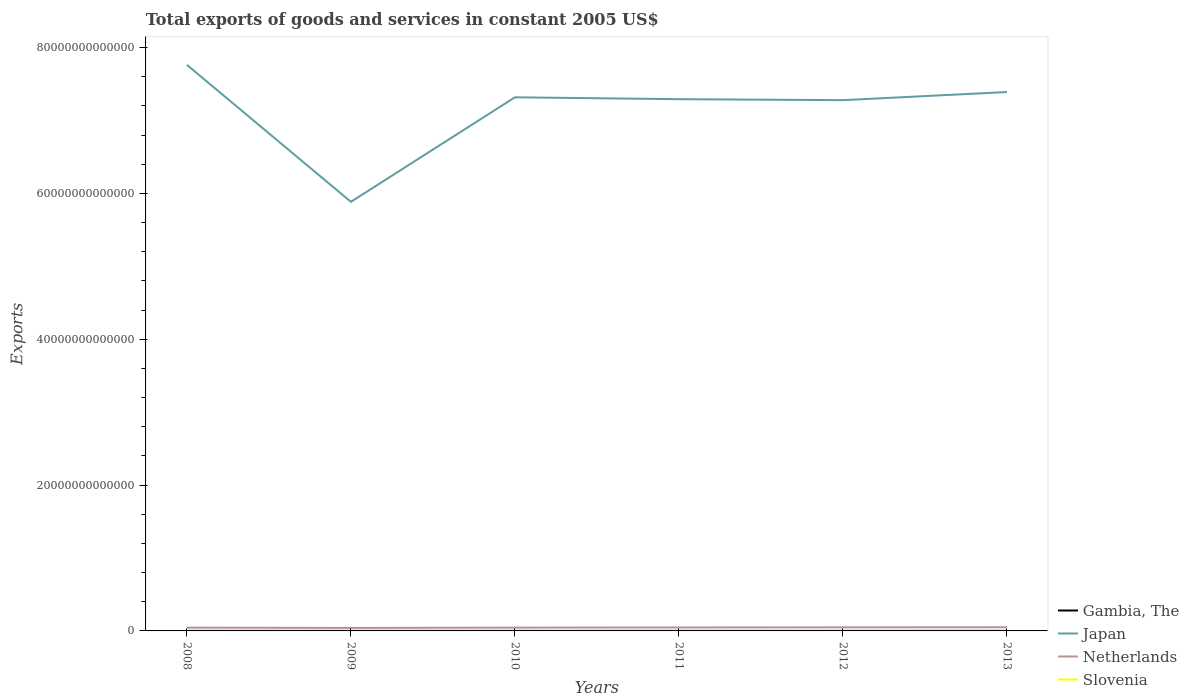How many different coloured lines are there?
Keep it short and to the point. 4. Is the number of lines equal to the number of legend labels?
Keep it short and to the point. Yes. Across all years, what is the maximum total exports of goods and services in Japan?
Ensure brevity in your answer.  5.88e+13. What is the total total exports of goods and services in Japan in the graph?
Your response must be concise. 1.88e+13. What is the difference between the highest and the second highest total exports of goods and services in Slovenia?
Give a very brief answer. 4.67e+09. What is the difference between the highest and the lowest total exports of goods and services in Gambia, The?
Provide a short and direct response. 3. Is the total exports of goods and services in Gambia, The strictly greater than the total exports of goods and services in Netherlands over the years?
Offer a very short reply. Yes. How many lines are there?
Your answer should be compact. 4. What is the difference between two consecutive major ticks on the Y-axis?
Provide a short and direct response. 2.00e+13. Does the graph contain any zero values?
Provide a succinct answer. No. Does the graph contain grids?
Offer a very short reply. No. What is the title of the graph?
Offer a very short reply. Total exports of goods and services in constant 2005 US$. Does "Latin America(all income levels)" appear as one of the legend labels in the graph?
Give a very brief answer. No. What is the label or title of the X-axis?
Offer a very short reply. Years. What is the label or title of the Y-axis?
Ensure brevity in your answer.  Exports. What is the Exports of Gambia, The in 2008?
Give a very brief answer. 3.05e+09. What is the Exports in Japan in 2008?
Ensure brevity in your answer.  7.76e+13. What is the Exports of Netherlands in 2008?
Offer a very short reply. 4.51e+11. What is the Exports of Slovenia in 2008?
Your response must be concise. 2.54e+1. What is the Exports of Gambia, The in 2009?
Your answer should be very brief. 4.56e+09. What is the Exports of Japan in 2009?
Ensure brevity in your answer.  5.88e+13. What is the Exports of Netherlands in 2009?
Your response must be concise. 4.11e+11. What is the Exports of Slovenia in 2009?
Keep it short and to the point. 2.12e+1. What is the Exports in Gambia, The in 2010?
Make the answer very short. 5.14e+09. What is the Exports in Japan in 2010?
Offer a very short reply. 7.32e+13. What is the Exports of Netherlands in 2010?
Provide a succinct answer. 4.54e+11. What is the Exports of Slovenia in 2010?
Keep it short and to the point. 2.33e+1. What is the Exports in Gambia, The in 2011?
Offer a very short reply. 5.48e+09. What is the Exports of Japan in 2011?
Offer a terse response. 7.29e+13. What is the Exports of Netherlands in 2011?
Keep it short and to the point. 4.74e+11. What is the Exports of Slovenia in 2011?
Provide a short and direct response. 2.49e+1. What is the Exports in Gambia, The in 2012?
Your answer should be compact. 6.75e+09. What is the Exports in Japan in 2012?
Your answer should be compact. 7.28e+13. What is the Exports of Netherlands in 2012?
Keep it short and to the point. 4.92e+11. What is the Exports in Slovenia in 2012?
Offer a terse response. 2.51e+1. What is the Exports of Gambia, The in 2013?
Your response must be concise. 6.73e+09. What is the Exports in Japan in 2013?
Your response must be concise. 7.39e+13. What is the Exports in Netherlands in 2013?
Your response must be concise. 5.03e+11. What is the Exports in Slovenia in 2013?
Ensure brevity in your answer.  2.58e+1. Across all years, what is the maximum Exports in Gambia, The?
Your answer should be compact. 6.75e+09. Across all years, what is the maximum Exports of Japan?
Give a very brief answer. 7.76e+13. Across all years, what is the maximum Exports of Netherlands?
Offer a terse response. 5.03e+11. Across all years, what is the maximum Exports of Slovenia?
Your answer should be compact. 2.58e+1. Across all years, what is the minimum Exports of Gambia, The?
Your answer should be very brief. 3.05e+09. Across all years, what is the minimum Exports in Japan?
Keep it short and to the point. 5.88e+13. Across all years, what is the minimum Exports of Netherlands?
Ensure brevity in your answer.  4.11e+11. Across all years, what is the minimum Exports of Slovenia?
Give a very brief answer. 2.12e+1. What is the total Exports of Gambia, The in the graph?
Provide a short and direct response. 3.17e+1. What is the total Exports of Japan in the graph?
Your answer should be compact. 4.29e+14. What is the total Exports of Netherlands in the graph?
Your answer should be compact. 2.79e+12. What is the total Exports of Slovenia in the graph?
Keep it short and to the point. 1.46e+11. What is the difference between the Exports in Gambia, The in 2008 and that in 2009?
Provide a short and direct response. -1.52e+09. What is the difference between the Exports of Japan in 2008 and that in 2009?
Offer a very short reply. 1.88e+13. What is the difference between the Exports of Netherlands in 2008 and that in 2009?
Give a very brief answer. 4.02e+1. What is the difference between the Exports of Slovenia in 2008 and that in 2009?
Your answer should be very brief. 4.21e+09. What is the difference between the Exports of Gambia, The in 2008 and that in 2010?
Offer a very short reply. -2.10e+09. What is the difference between the Exports of Japan in 2008 and that in 2010?
Provide a short and direct response. 4.45e+12. What is the difference between the Exports in Netherlands in 2008 and that in 2010?
Your answer should be compact. -3.14e+09. What is the difference between the Exports in Slovenia in 2008 and that in 2010?
Keep it short and to the point. 2.06e+09. What is the difference between the Exports of Gambia, The in 2008 and that in 2011?
Give a very brief answer. -2.43e+09. What is the difference between the Exports in Japan in 2008 and that in 2011?
Your response must be concise. 4.71e+12. What is the difference between the Exports in Netherlands in 2008 and that in 2011?
Make the answer very short. -2.32e+1. What is the difference between the Exports of Slovenia in 2008 and that in 2011?
Offer a very short reply. 4.52e+08. What is the difference between the Exports in Gambia, The in 2008 and that in 2012?
Offer a very short reply. -3.70e+09. What is the difference between the Exports in Japan in 2008 and that in 2012?
Your answer should be very brief. 4.84e+12. What is the difference between the Exports of Netherlands in 2008 and that in 2012?
Offer a very short reply. -4.11e+1. What is the difference between the Exports in Slovenia in 2008 and that in 2012?
Provide a succinct answer. 3.06e+08. What is the difference between the Exports in Gambia, The in 2008 and that in 2013?
Your answer should be very brief. -3.68e+09. What is the difference between the Exports of Japan in 2008 and that in 2013?
Give a very brief answer. 3.72e+12. What is the difference between the Exports of Netherlands in 2008 and that in 2013?
Provide a short and direct response. -5.17e+1. What is the difference between the Exports of Slovenia in 2008 and that in 2013?
Provide a succinct answer. -4.59e+08. What is the difference between the Exports of Gambia, The in 2009 and that in 2010?
Offer a very short reply. -5.81e+08. What is the difference between the Exports of Japan in 2009 and that in 2010?
Make the answer very short. -1.43e+13. What is the difference between the Exports of Netherlands in 2009 and that in 2010?
Make the answer very short. -4.33e+1. What is the difference between the Exports in Slovenia in 2009 and that in 2010?
Your answer should be compact. -2.15e+09. What is the difference between the Exports of Gambia, The in 2009 and that in 2011?
Keep it short and to the point. -9.14e+08. What is the difference between the Exports in Japan in 2009 and that in 2011?
Ensure brevity in your answer.  -1.41e+13. What is the difference between the Exports of Netherlands in 2009 and that in 2011?
Your response must be concise. -6.33e+1. What is the difference between the Exports in Slovenia in 2009 and that in 2011?
Provide a short and direct response. -3.76e+09. What is the difference between the Exports of Gambia, The in 2009 and that in 2012?
Offer a terse response. -2.18e+09. What is the difference between the Exports of Japan in 2009 and that in 2012?
Offer a very short reply. -1.39e+13. What is the difference between the Exports of Netherlands in 2009 and that in 2012?
Keep it short and to the point. -8.13e+1. What is the difference between the Exports in Slovenia in 2009 and that in 2012?
Provide a short and direct response. -3.90e+09. What is the difference between the Exports of Gambia, The in 2009 and that in 2013?
Your answer should be compact. -2.16e+09. What is the difference between the Exports in Japan in 2009 and that in 2013?
Offer a very short reply. -1.51e+13. What is the difference between the Exports of Netherlands in 2009 and that in 2013?
Give a very brief answer. -9.19e+1. What is the difference between the Exports of Slovenia in 2009 and that in 2013?
Provide a succinct answer. -4.67e+09. What is the difference between the Exports in Gambia, The in 2010 and that in 2011?
Make the answer very short. -3.33e+08. What is the difference between the Exports of Japan in 2010 and that in 2011?
Give a very brief answer. 2.60e+11. What is the difference between the Exports in Netherlands in 2010 and that in 2011?
Offer a terse response. -2.00e+1. What is the difference between the Exports in Slovenia in 2010 and that in 2011?
Give a very brief answer. -1.61e+09. What is the difference between the Exports in Gambia, The in 2010 and that in 2012?
Your answer should be compact. -1.60e+09. What is the difference between the Exports of Japan in 2010 and that in 2012?
Ensure brevity in your answer.  3.92e+11. What is the difference between the Exports in Netherlands in 2010 and that in 2012?
Your response must be concise. -3.80e+1. What is the difference between the Exports of Slovenia in 2010 and that in 2012?
Give a very brief answer. -1.75e+09. What is the difference between the Exports in Gambia, The in 2010 and that in 2013?
Give a very brief answer. -1.58e+09. What is the difference between the Exports of Japan in 2010 and that in 2013?
Provide a succinct answer. -7.21e+11. What is the difference between the Exports of Netherlands in 2010 and that in 2013?
Your answer should be very brief. -4.86e+1. What is the difference between the Exports in Slovenia in 2010 and that in 2013?
Provide a succinct answer. -2.52e+09. What is the difference between the Exports of Gambia, The in 2011 and that in 2012?
Provide a short and direct response. -1.27e+09. What is the difference between the Exports of Japan in 2011 and that in 2012?
Give a very brief answer. 1.32e+11. What is the difference between the Exports of Netherlands in 2011 and that in 2012?
Give a very brief answer. -1.80e+1. What is the difference between the Exports of Slovenia in 2011 and that in 2012?
Your answer should be very brief. -1.46e+08. What is the difference between the Exports in Gambia, The in 2011 and that in 2013?
Your response must be concise. -1.25e+09. What is the difference between the Exports of Japan in 2011 and that in 2013?
Give a very brief answer. -9.81e+11. What is the difference between the Exports of Netherlands in 2011 and that in 2013?
Your answer should be compact. -2.86e+1. What is the difference between the Exports of Slovenia in 2011 and that in 2013?
Provide a succinct answer. -9.11e+08. What is the difference between the Exports of Gambia, The in 2012 and that in 2013?
Your answer should be very brief. 2.00e+07. What is the difference between the Exports in Japan in 2012 and that in 2013?
Give a very brief answer. -1.11e+12. What is the difference between the Exports in Netherlands in 2012 and that in 2013?
Provide a short and direct response. -1.06e+1. What is the difference between the Exports in Slovenia in 2012 and that in 2013?
Keep it short and to the point. -7.65e+08. What is the difference between the Exports in Gambia, The in 2008 and the Exports in Japan in 2009?
Make the answer very short. -5.88e+13. What is the difference between the Exports in Gambia, The in 2008 and the Exports in Netherlands in 2009?
Offer a very short reply. -4.08e+11. What is the difference between the Exports in Gambia, The in 2008 and the Exports in Slovenia in 2009?
Provide a short and direct response. -1.81e+1. What is the difference between the Exports of Japan in 2008 and the Exports of Netherlands in 2009?
Provide a short and direct response. 7.72e+13. What is the difference between the Exports in Japan in 2008 and the Exports in Slovenia in 2009?
Ensure brevity in your answer.  7.76e+13. What is the difference between the Exports of Netherlands in 2008 and the Exports of Slovenia in 2009?
Provide a short and direct response. 4.30e+11. What is the difference between the Exports in Gambia, The in 2008 and the Exports in Japan in 2010?
Your response must be concise. -7.32e+13. What is the difference between the Exports in Gambia, The in 2008 and the Exports in Netherlands in 2010?
Provide a succinct answer. -4.51e+11. What is the difference between the Exports of Gambia, The in 2008 and the Exports of Slovenia in 2010?
Make the answer very short. -2.03e+1. What is the difference between the Exports in Japan in 2008 and the Exports in Netherlands in 2010?
Provide a short and direct response. 7.72e+13. What is the difference between the Exports in Japan in 2008 and the Exports in Slovenia in 2010?
Offer a very short reply. 7.76e+13. What is the difference between the Exports of Netherlands in 2008 and the Exports of Slovenia in 2010?
Provide a succinct answer. 4.28e+11. What is the difference between the Exports in Gambia, The in 2008 and the Exports in Japan in 2011?
Ensure brevity in your answer.  -7.29e+13. What is the difference between the Exports of Gambia, The in 2008 and the Exports of Netherlands in 2011?
Provide a succinct answer. -4.71e+11. What is the difference between the Exports of Gambia, The in 2008 and the Exports of Slovenia in 2011?
Keep it short and to the point. -2.19e+1. What is the difference between the Exports in Japan in 2008 and the Exports in Netherlands in 2011?
Your response must be concise. 7.72e+13. What is the difference between the Exports of Japan in 2008 and the Exports of Slovenia in 2011?
Make the answer very short. 7.76e+13. What is the difference between the Exports in Netherlands in 2008 and the Exports in Slovenia in 2011?
Your response must be concise. 4.26e+11. What is the difference between the Exports of Gambia, The in 2008 and the Exports of Japan in 2012?
Offer a very short reply. -7.28e+13. What is the difference between the Exports of Gambia, The in 2008 and the Exports of Netherlands in 2012?
Your response must be concise. -4.89e+11. What is the difference between the Exports of Gambia, The in 2008 and the Exports of Slovenia in 2012?
Give a very brief answer. -2.20e+1. What is the difference between the Exports in Japan in 2008 and the Exports in Netherlands in 2012?
Your response must be concise. 7.71e+13. What is the difference between the Exports of Japan in 2008 and the Exports of Slovenia in 2012?
Provide a succinct answer. 7.76e+13. What is the difference between the Exports in Netherlands in 2008 and the Exports in Slovenia in 2012?
Keep it short and to the point. 4.26e+11. What is the difference between the Exports of Gambia, The in 2008 and the Exports of Japan in 2013?
Your response must be concise. -7.39e+13. What is the difference between the Exports of Gambia, The in 2008 and the Exports of Netherlands in 2013?
Ensure brevity in your answer.  -5.00e+11. What is the difference between the Exports of Gambia, The in 2008 and the Exports of Slovenia in 2013?
Your answer should be compact. -2.28e+1. What is the difference between the Exports in Japan in 2008 and the Exports in Netherlands in 2013?
Provide a short and direct response. 7.71e+13. What is the difference between the Exports of Japan in 2008 and the Exports of Slovenia in 2013?
Offer a terse response. 7.76e+13. What is the difference between the Exports of Netherlands in 2008 and the Exports of Slovenia in 2013?
Your response must be concise. 4.25e+11. What is the difference between the Exports in Gambia, The in 2009 and the Exports in Japan in 2010?
Offer a terse response. -7.32e+13. What is the difference between the Exports in Gambia, The in 2009 and the Exports in Netherlands in 2010?
Your answer should be compact. -4.50e+11. What is the difference between the Exports of Gambia, The in 2009 and the Exports of Slovenia in 2010?
Your response must be concise. -1.87e+1. What is the difference between the Exports in Japan in 2009 and the Exports in Netherlands in 2010?
Your answer should be compact. 5.84e+13. What is the difference between the Exports of Japan in 2009 and the Exports of Slovenia in 2010?
Your response must be concise. 5.88e+13. What is the difference between the Exports of Netherlands in 2009 and the Exports of Slovenia in 2010?
Ensure brevity in your answer.  3.88e+11. What is the difference between the Exports in Gambia, The in 2009 and the Exports in Japan in 2011?
Keep it short and to the point. -7.29e+13. What is the difference between the Exports of Gambia, The in 2009 and the Exports of Netherlands in 2011?
Your answer should be compact. -4.70e+11. What is the difference between the Exports in Gambia, The in 2009 and the Exports in Slovenia in 2011?
Make the answer very short. -2.03e+1. What is the difference between the Exports of Japan in 2009 and the Exports of Netherlands in 2011?
Keep it short and to the point. 5.84e+13. What is the difference between the Exports of Japan in 2009 and the Exports of Slovenia in 2011?
Offer a very short reply. 5.88e+13. What is the difference between the Exports in Netherlands in 2009 and the Exports in Slovenia in 2011?
Make the answer very short. 3.86e+11. What is the difference between the Exports in Gambia, The in 2009 and the Exports in Japan in 2012?
Your answer should be very brief. -7.28e+13. What is the difference between the Exports in Gambia, The in 2009 and the Exports in Netherlands in 2012?
Keep it short and to the point. -4.88e+11. What is the difference between the Exports in Gambia, The in 2009 and the Exports in Slovenia in 2012?
Your answer should be very brief. -2.05e+1. What is the difference between the Exports of Japan in 2009 and the Exports of Netherlands in 2012?
Your answer should be very brief. 5.84e+13. What is the difference between the Exports in Japan in 2009 and the Exports in Slovenia in 2012?
Make the answer very short. 5.88e+13. What is the difference between the Exports of Netherlands in 2009 and the Exports of Slovenia in 2012?
Your answer should be very brief. 3.86e+11. What is the difference between the Exports of Gambia, The in 2009 and the Exports of Japan in 2013?
Offer a very short reply. -7.39e+13. What is the difference between the Exports of Gambia, The in 2009 and the Exports of Netherlands in 2013?
Provide a succinct answer. -4.98e+11. What is the difference between the Exports in Gambia, The in 2009 and the Exports in Slovenia in 2013?
Ensure brevity in your answer.  -2.13e+1. What is the difference between the Exports of Japan in 2009 and the Exports of Netherlands in 2013?
Ensure brevity in your answer.  5.83e+13. What is the difference between the Exports of Japan in 2009 and the Exports of Slovenia in 2013?
Offer a terse response. 5.88e+13. What is the difference between the Exports of Netherlands in 2009 and the Exports of Slovenia in 2013?
Give a very brief answer. 3.85e+11. What is the difference between the Exports of Gambia, The in 2010 and the Exports of Japan in 2011?
Your answer should be compact. -7.29e+13. What is the difference between the Exports of Gambia, The in 2010 and the Exports of Netherlands in 2011?
Provide a succinct answer. -4.69e+11. What is the difference between the Exports in Gambia, The in 2010 and the Exports in Slovenia in 2011?
Provide a succinct answer. -1.98e+1. What is the difference between the Exports of Japan in 2010 and the Exports of Netherlands in 2011?
Provide a succinct answer. 7.27e+13. What is the difference between the Exports in Japan in 2010 and the Exports in Slovenia in 2011?
Provide a succinct answer. 7.32e+13. What is the difference between the Exports of Netherlands in 2010 and the Exports of Slovenia in 2011?
Your answer should be compact. 4.29e+11. What is the difference between the Exports of Gambia, The in 2010 and the Exports of Japan in 2012?
Ensure brevity in your answer.  -7.28e+13. What is the difference between the Exports of Gambia, The in 2010 and the Exports of Netherlands in 2012?
Give a very brief answer. -4.87e+11. What is the difference between the Exports of Gambia, The in 2010 and the Exports of Slovenia in 2012?
Your response must be concise. -1.99e+1. What is the difference between the Exports of Japan in 2010 and the Exports of Netherlands in 2012?
Give a very brief answer. 7.27e+13. What is the difference between the Exports of Japan in 2010 and the Exports of Slovenia in 2012?
Provide a succinct answer. 7.32e+13. What is the difference between the Exports in Netherlands in 2010 and the Exports in Slovenia in 2012?
Make the answer very short. 4.29e+11. What is the difference between the Exports of Gambia, The in 2010 and the Exports of Japan in 2013?
Make the answer very short. -7.39e+13. What is the difference between the Exports in Gambia, The in 2010 and the Exports in Netherlands in 2013?
Provide a short and direct response. -4.98e+11. What is the difference between the Exports of Gambia, The in 2010 and the Exports of Slovenia in 2013?
Your answer should be compact. -2.07e+1. What is the difference between the Exports in Japan in 2010 and the Exports in Netherlands in 2013?
Your response must be concise. 7.27e+13. What is the difference between the Exports of Japan in 2010 and the Exports of Slovenia in 2013?
Keep it short and to the point. 7.32e+13. What is the difference between the Exports of Netherlands in 2010 and the Exports of Slovenia in 2013?
Provide a succinct answer. 4.29e+11. What is the difference between the Exports in Gambia, The in 2011 and the Exports in Japan in 2012?
Offer a very short reply. -7.28e+13. What is the difference between the Exports in Gambia, The in 2011 and the Exports in Netherlands in 2012?
Keep it short and to the point. -4.87e+11. What is the difference between the Exports of Gambia, The in 2011 and the Exports of Slovenia in 2012?
Offer a very short reply. -1.96e+1. What is the difference between the Exports in Japan in 2011 and the Exports in Netherlands in 2012?
Offer a terse response. 7.24e+13. What is the difference between the Exports of Japan in 2011 and the Exports of Slovenia in 2012?
Ensure brevity in your answer.  7.29e+13. What is the difference between the Exports in Netherlands in 2011 and the Exports in Slovenia in 2012?
Provide a succinct answer. 4.49e+11. What is the difference between the Exports of Gambia, The in 2011 and the Exports of Japan in 2013?
Provide a short and direct response. -7.39e+13. What is the difference between the Exports in Gambia, The in 2011 and the Exports in Netherlands in 2013?
Ensure brevity in your answer.  -4.98e+11. What is the difference between the Exports of Gambia, The in 2011 and the Exports of Slovenia in 2013?
Your answer should be compact. -2.03e+1. What is the difference between the Exports in Japan in 2011 and the Exports in Netherlands in 2013?
Your answer should be compact. 7.24e+13. What is the difference between the Exports in Japan in 2011 and the Exports in Slovenia in 2013?
Your answer should be very brief. 7.29e+13. What is the difference between the Exports of Netherlands in 2011 and the Exports of Slovenia in 2013?
Your answer should be compact. 4.49e+11. What is the difference between the Exports of Gambia, The in 2012 and the Exports of Japan in 2013?
Your response must be concise. -7.39e+13. What is the difference between the Exports of Gambia, The in 2012 and the Exports of Netherlands in 2013?
Provide a succinct answer. -4.96e+11. What is the difference between the Exports of Gambia, The in 2012 and the Exports of Slovenia in 2013?
Offer a very short reply. -1.91e+1. What is the difference between the Exports in Japan in 2012 and the Exports in Netherlands in 2013?
Your answer should be compact. 7.23e+13. What is the difference between the Exports of Japan in 2012 and the Exports of Slovenia in 2013?
Keep it short and to the point. 7.28e+13. What is the difference between the Exports of Netherlands in 2012 and the Exports of Slovenia in 2013?
Offer a very short reply. 4.67e+11. What is the average Exports in Gambia, The per year?
Give a very brief answer. 5.28e+09. What is the average Exports in Japan per year?
Provide a short and direct response. 7.15e+13. What is the average Exports of Netherlands per year?
Your answer should be compact. 4.64e+11. What is the average Exports in Slovenia per year?
Your answer should be very brief. 2.43e+1. In the year 2008, what is the difference between the Exports of Gambia, The and Exports of Japan?
Provide a succinct answer. -7.76e+13. In the year 2008, what is the difference between the Exports in Gambia, The and Exports in Netherlands?
Your answer should be compact. -4.48e+11. In the year 2008, what is the difference between the Exports of Gambia, The and Exports of Slovenia?
Offer a very short reply. -2.23e+1. In the year 2008, what is the difference between the Exports of Japan and Exports of Netherlands?
Give a very brief answer. 7.72e+13. In the year 2008, what is the difference between the Exports of Japan and Exports of Slovenia?
Give a very brief answer. 7.76e+13. In the year 2008, what is the difference between the Exports of Netherlands and Exports of Slovenia?
Give a very brief answer. 4.26e+11. In the year 2009, what is the difference between the Exports of Gambia, The and Exports of Japan?
Ensure brevity in your answer.  -5.88e+13. In the year 2009, what is the difference between the Exports in Gambia, The and Exports in Netherlands?
Offer a terse response. -4.07e+11. In the year 2009, what is the difference between the Exports in Gambia, The and Exports in Slovenia?
Offer a very short reply. -1.66e+1. In the year 2009, what is the difference between the Exports in Japan and Exports in Netherlands?
Provide a short and direct response. 5.84e+13. In the year 2009, what is the difference between the Exports in Japan and Exports in Slovenia?
Your answer should be very brief. 5.88e+13. In the year 2009, what is the difference between the Exports of Netherlands and Exports of Slovenia?
Provide a succinct answer. 3.90e+11. In the year 2010, what is the difference between the Exports of Gambia, The and Exports of Japan?
Offer a terse response. -7.32e+13. In the year 2010, what is the difference between the Exports in Gambia, The and Exports in Netherlands?
Provide a short and direct response. -4.49e+11. In the year 2010, what is the difference between the Exports in Gambia, The and Exports in Slovenia?
Keep it short and to the point. -1.82e+1. In the year 2010, what is the difference between the Exports of Japan and Exports of Netherlands?
Ensure brevity in your answer.  7.27e+13. In the year 2010, what is the difference between the Exports in Japan and Exports in Slovenia?
Give a very brief answer. 7.32e+13. In the year 2010, what is the difference between the Exports of Netherlands and Exports of Slovenia?
Offer a terse response. 4.31e+11. In the year 2011, what is the difference between the Exports of Gambia, The and Exports of Japan?
Make the answer very short. -7.29e+13. In the year 2011, what is the difference between the Exports of Gambia, The and Exports of Netherlands?
Your answer should be compact. -4.69e+11. In the year 2011, what is the difference between the Exports of Gambia, The and Exports of Slovenia?
Keep it short and to the point. -1.94e+1. In the year 2011, what is the difference between the Exports of Japan and Exports of Netherlands?
Provide a short and direct response. 7.24e+13. In the year 2011, what is the difference between the Exports in Japan and Exports in Slovenia?
Provide a succinct answer. 7.29e+13. In the year 2011, what is the difference between the Exports of Netherlands and Exports of Slovenia?
Your answer should be very brief. 4.49e+11. In the year 2012, what is the difference between the Exports of Gambia, The and Exports of Japan?
Your response must be concise. -7.28e+13. In the year 2012, what is the difference between the Exports in Gambia, The and Exports in Netherlands?
Your answer should be very brief. -4.86e+11. In the year 2012, what is the difference between the Exports in Gambia, The and Exports in Slovenia?
Provide a succinct answer. -1.83e+1. In the year 2012, what is the difference between the Exports of Japan and Exports of Netherlands?
Keep it short and to the point. 7.23e+13. In the year 2012, what is the difference between the Exports of Japan and Exports of Slovenia?
Offer a terse response. 7.28e+13. In the year 2012, what is the difference between the Exports of Netherlands and Exports of Slovenia?
Offer a terse response. 4.67e+11. In the year 2013, what is the difference between the Exports in Gambia, The and Exports in Japan?
Ensure brevity in your answer.  -7.39e+13. In the year 2013, what is the difference between the Exports of Gambia, The and Exports of Netherlands?
Your answer should be very brief. -4.96e+11. In the year 2013, what is the difference between the Exports of Gambia, The and Exports of Slovenia?
Make the answer very short. -1.91e+1. In the year 2013, what is the difference between the Exports in Japan and Exports in Netherlands?
Offer a terse response. 7.34e+13. In the year 2013, what is the difference between the Exports in Japan and Exports in Slovenia?
Your answer should be compact. 7.39e+13. In the year 2013, what is the difference between the Exports in Netherlands and Exports in Slovenia?
Offer a terse response. 4.77e+11. What is the ratio of the Exports in Gambia, The in 2008 to that in 2009?
Ensure brevity in your answer.  0.67. What is the ratio of the Exports of Japan in 2008 to that in 2009?
Offer a very short reply. 1.32. What is the ratio of the Exports of Netherlands in 2008 to that in 2009?
Make the answer very short. 1.1. What is the ratio of the Exports of Slovenia in 2008 to that in 2009?
Give a very brief answer. 1.2. What is the ratio of the Exports of Gambia, The in 2008 to that in 2010?
Your response must be concise. 0.59. What is the ratio of the Exports of Japan in 2008 to that in 2010?
Your answer should be compact. 1.06. What is the ratio of the Exports in Slovenia in 2008 to that in 2010?
Your response must be concise. 1.09. What is the ratio of the Exports in Gambia, The in 2008 to that in 2011?
Your answer should be very brief. 0.56. What is the ratio of the Exports of Japan in 2008 to that in 2011?
Ensure brevity in your answer.  1.06. What is the ratio of the Exports of Netherlands in 2008 to that in 2011?
Your answer should be very brief. 0.95. What is the ratio of the Exports of Slovenia in 2008 to that in 2011?
Ensure brevity in your answer.  1.02. What is the ratio of the Exports of Gambia, The in 2008 to that in 2012?
Provide a short and direct response. 0.45. What is the ratio of the Exports in Japan in 2008 to that in 2012?
Your answer should be very brief. 1.07. What is the ratio of the Exports of Netherlands in 2008 to that in 2012?
Give a very brief answer. 0.92. What is the ratio of the Exports in Slovenia in 2008 to that in 2012?
Your answer should be compact. 1.01. What is the ratio of the Exports in Gambia, The in 2008 to that in 2013?
Offer a very short reply. 0.45. What is the ratio of the Exports of Japan in 2008 to that in 2013?
Provide a short and direct response. 1.05. What is the ratio of the Exports in Netherlands in 2008 to that in 2013?
Ensure brevity in your answer.  0.9. What is the ratio of the Exports in Slovenia in 2008 to that in 2013?
Your response must be concise. 0.98. What is the ratio of the Exports of Gambia, The in 2009 to that in 2010?
Offer a very short reply. 0.89. What is the ratio of the Exports of Japan in 2009 to that in 2010?
Your response must be concise. 0.8. What is the ratio of the Exports in Netherlands in 2009 to that in 2010?
Make the answer very short. 0.9. What is the ratio of the Exports of Slovenia in 2009 to that in 2010?
Your response must be concise. 0.91. What is the ratio of the Exports of Gambia, The in 2009 to that in 2011?
Provide a succinct answer. 0.83. What is the ratio of the Exports of Japan in 2009 to that in 2011?
Provide a succinct answer. 0.81. What is the ratio of the Exports of Netherlands in 2009 to that in 2011?
Give a very brief answer. 0.87. What is the ratio of the Exports of Slovenia in 2009 to that in 2011?
Your answer should be very brief. 0.85. What is the ratio of the Exports in Gambia, The in 2009 to that in 2012?
Give a very brief answer. 0.68. What is the ratio of the Exports in Japan in 2009 to that in 2012?
Provide a succinct answer. 0.81. What is the ratio of the Exports of Netherlands in 2009 to that in 2012?
Your response must be concise. 0.83. What is the ratio of the Exports in Slovenia in 2009 to that in 2012?
Offer a very short reply. 0.84. What is the ratio of the Exports of Gambia, The in 2009 to that in 2013?
Give a very brief answer. 0.68. What is the ratio of the Exports of Japan in 2009 to that in 2013?
Offer a terse response. 0.8. What is the ratio of the Exports of Netherlands in 2009 to that in 2013?
Keep it short and to the point. 0.82. What is the ratio of the Exports in Slovenia in 2009 to that in 2013?
Keep it short and to the point. 0.82. What is the ratio of the Exports in Gambia, The in 2010 to that in 2011?
Your answer should be very brief. 0.94. What is the ratio of the Exports of Japan in 2010 to that in 2011?
Provide a short and direct response. 1. What is the ratio of the Exports of Netherlands in 2010 to that in 2011?
Your answer should be very brief. 0.96. What is the ratio of the Exports in Slovenia in 2010 to that in 2011?
Give a very brief answer. 0.94. What is the ratio of the Exports in Gambia, The in 2010 to that in 2012?
Give a very brief answer. 0.76. What is the ratio of the Exports of Japan in 2010 to that in 2012?
Make the answer very short. 1.01. What is the ratio of the Exports of Netherlands in 2010 to that in 2012?
Give a very brief answer. 0.92. What is the ratio of the Exports in Slovenia in 2010 to that in 2012?
Offer a very short reply. 0.93. What is the ratio of the Exports in Gambia, The in 2010 to that in 2013?
Make the answer very short. 0.76. What is the ratio of the Exports of Japan in 2010 to that in 2013?
Make the answer very short. 0.99. What is the ratio of the Exports of Netherlands in 2010 to that in 2013?
Provide a short and direct response. 0.9. What is the ratio of the Exports of Slovenia in 2010 to that in 2013?
Provide a succinct answer. 0.9. What is the ratio of the Exports of Gambia, The in 2011 to that in 2012?
Your response must be concise. 0.81. What is the ratio of the Exports of Netherlands in 2011 to that in 2012?
Your answer should be very brief. 0.96. What is the ratio of the Exports in Slovenia in 2011 to that in 2012?
Offer a very short reply. 0.99. What is the ratio of the Exports of Gambia, The in 2011 to that in 2013?
Your answer should be very brief. 0.81. What is the ratio of the Exports of Japan in 2011 to that in 2013?
Your answer should be compact. 0.99. What is the ratio of the Exports in Netherlands in 2011 to that in 2013?
Your answer should be compact. 0.94. What is the ratio of the Exports of Slovenia in 2011 to that in 2013?
Provide a short and direct response. 0.96. What is the ratio of the Exports in Japan in 2012 to that in 2013?
Ensure brevity in your answer.  0.98. What is the ratio of the Exports of Netherlands in 2012 to that in 2013?
Your answer should be compact. 0.98. What is the ratio of the Exports of Slovenia in 2012 to that in 2013?
Your response must be concise. 0.97. What is the difference between the highest and the second highest Exports in Japan?
Your answer should be compact. 3.72e+12. What is the difference between the highest and the second highest Exports of Netherlands?
Your answer should be compact. 1.06e+1. What is the difference between the highest and the second highest Exports in Slovenia?
Your response must be concise. 4.59e+08. What is the difference between the highest and the lowest Exports of Gambia, The?
Provide a short and direct response. 3.70e+09. What is the difference between the highest and the lowest Exports of Japan?
Give a very brief answer. 1.88e+13. What is the difference between the highest and the lowest Exports in Netherlands?
Ensure brevity in your answer.  9.19e+1. What is the difference between the highest and the lowest Exports of Slovenia?
Offer a very short reply. 4.67e+09. 